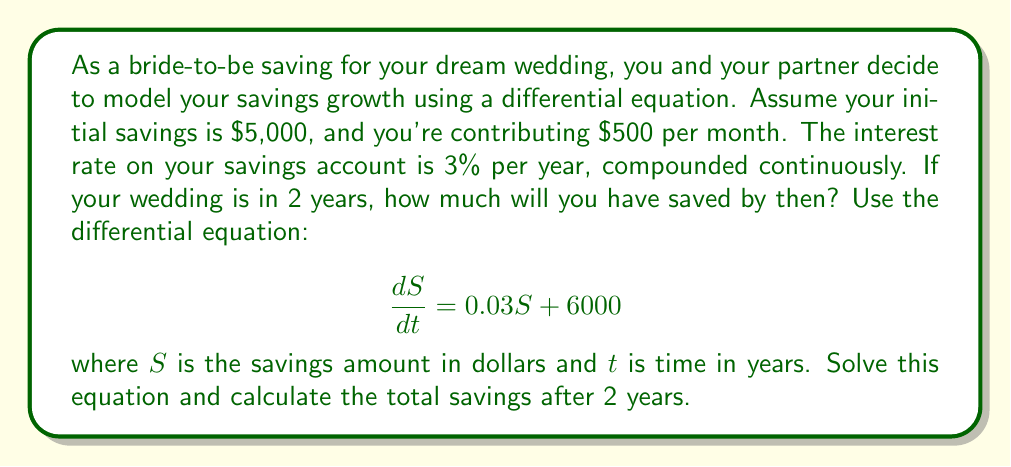Could you help me with this problem? Let's solve this differential equation step-by-step:

1) The given differential equation is:
   $$\frac{dS}{dt} = 0.03S + 6000$$

2) This is a linear first-order differential equation of the form:
   $$\frac{dS}{dt} + P(t)S = Q(t)$$
   where $P(t) = -0.03$ and $Q(t) = 6000$

3) The integrating factor is:
   $$\mu(t) = e^{\int P(t)dt} = e^{-0.03t}$$

4) Multiply both sides of the equation by $\mu(t)$:
   $$e^{-0.03t}\frac{dS}{dt} + 0.03e^{-0.03t}S = 6000e^{-0.03t}$$

5) The left side is now the derivative of $e^{-0.03t}S$, so we can write:
   $$\frac{d}{dt}(e^{-0.03t}S) = 6000e^{-0.03t}$$

6) Integrate both sides:
   $$e^{-0.03t}S = -200000e^{-0.03t} + C$$

7) Solve for $S$:
   $$S = -200000 + Ce^{0.03t}$$

8) Use the initial condition $S(0) = 5000$ to find $C$:
   $$5000 = -200000 + C$$
   $$C = 205000$$

9) The general solution is:
   $$S(t) = -200000 + 205000e^{0.03t}$$

10) To find the savings after 2 years, calculate $S(2)$:
    $$S(2) = -200000 + 205000e^{0.03(2)}$$
    $$S(2) = -200000 + 205000e^{0.06}$$
    $$S(2) = -200000 + 205000(1.061836)$$
    $$S(2) = 17676.38$$

Therefore, after 2 years, you will have saved approximately $17,676.38.
Answer: $17,676.38 